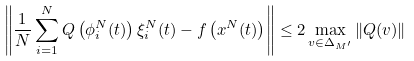<formula> <loc_0><loc_0><loc_500><loc_500>& \left \| \frac { 1 } { N } \sum _ { i = 1 } ^ { N } Q \left ( \phi _ { i } ^ { N } ( t ) \right ) \xi _ { i } ^ { N } ( t ) - f \left ( x ^ { N } ( t ) \right ) \right \| \leq 2 \max _ { v \in \Delta _ { M ^ { \prime } } } \left \| Q ( v ) \right \|</formula> 